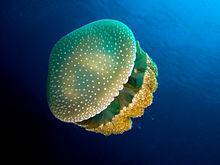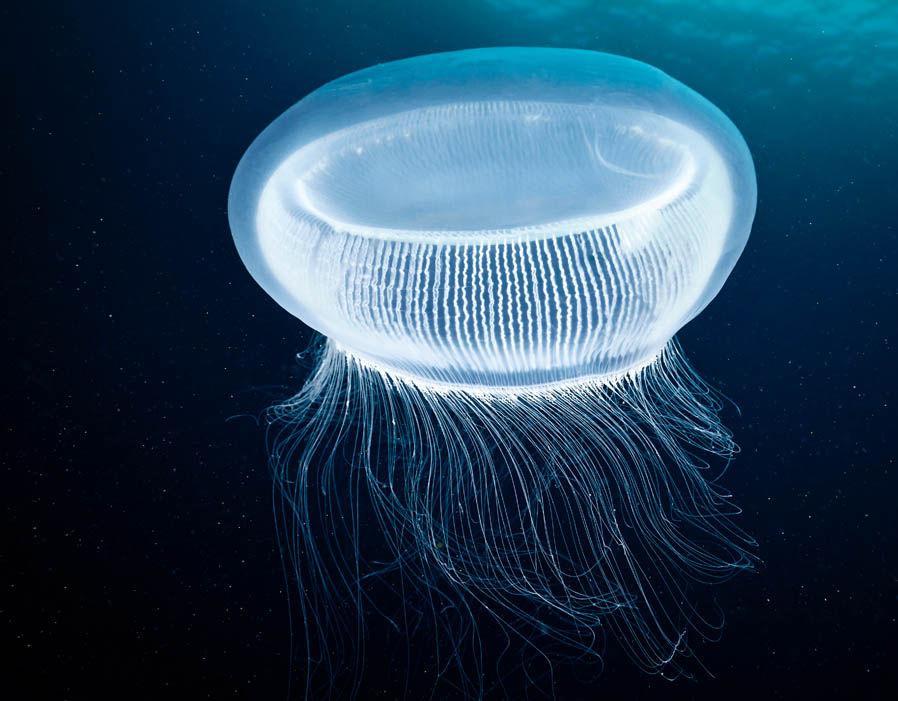The first image is the image on the left, the second image is the image on the right. Examine the images to the left and right. Is the description "There is not less than one scuba diver" accurate? Answer yes or no. No. 